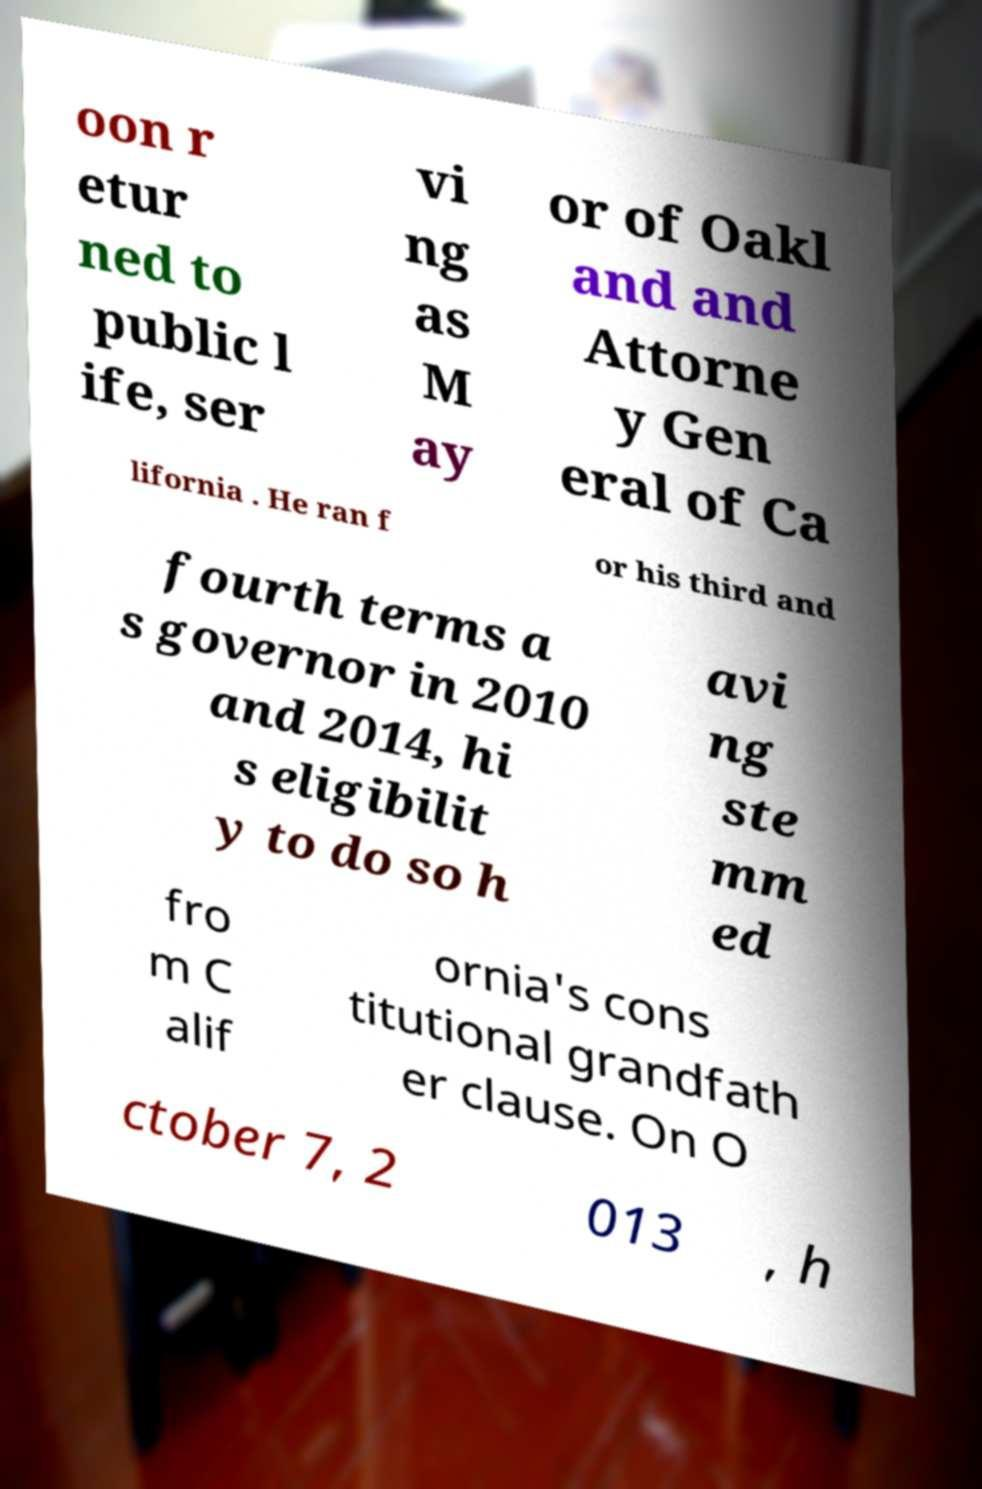Could you extract and type out the text from this image? oon r etur ned to public l ife, ser vi ng as M ay or of Oakl and and Attorne y Gen eral of Ca lifornia . He ran f or his third and fourth terms a s governor in 2010 and 2014, hi s eligibilit y to do so h avi ng ste mm ed fro m C alif ornia's cons titutional grandfath er clause. On O ctober 7, 2 013 , h 